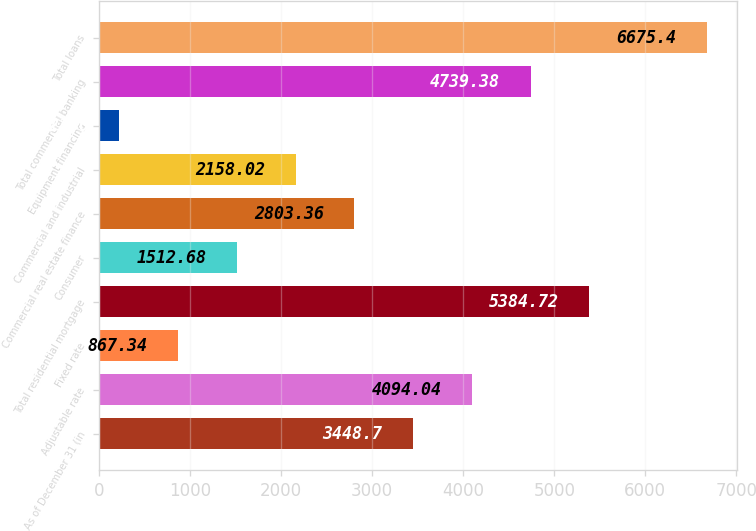Convert chart. <chart><loc_0><loc_0><loc_500><loc_500><bar_chart><fcel>As of December 31 (in<fcel>Adjustable rate<fcel>Fixed rate<fcel>Total residential mortgage<fcel>Consumer<fcel>Commercial real estate finance<fcel>Commercial and industrial<fcel>Equipment financing<fcel>Total commercial banking<fcel>Total loans<nl><fcel>3448.7<fcel>4094.04<fcel>867.34<fcel>5384.72<fcel>1512.68<fcel>2803.36<fcel>2158.02<fcel>222<fcel>4739.38<fcel>6675.4<nl></chart> 